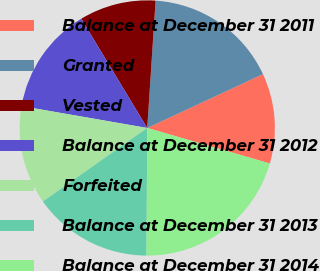<chart> <loc_0><loc_0><loc_500><loc_500><pie_chart><fcel>Balance at December 31 2011<fcel>Granted<fcel>Vested<fcel>Balance at December 31 2012<fcel>Forfeited<fcel>Balance at December 31 2013<fcel>Balance at December 31 2014<nl><fcel>11.42%<fcel>17.03%<fcel>9.69%<fcel>13.61%<fcel>12.51%<fcel>15.14%<fcel>20.61%<nl></chart> 